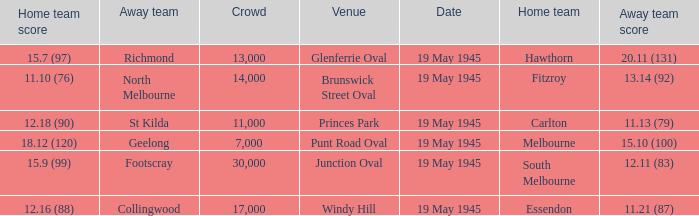Would you mind parsing the complete table? {'header': ['Home team score', 'Away team', 'Crowd', 'Venue', 'Date', 'Home team', 'Away team score'], 'rows': [['15.7 (97)', 'Richmond', '13,000', 'Glenferrie Oval', '19 May 1945', 'Hawthorn', '20.11 (131)'], ['11.10 (76)', 'North Melbourne', '14,000', 'Brunswick Street Oval', '19 May 1945', 'Fitzroy', '13.14 (92)'], ['12.18 (90)', 'St Kilda', '11,000', 'Princes Park', '19 May 1945', 'Carlton', '11.13 (79)'], ['18.12 (120)', 'Geelong', '7,000', 'Punt Road Oval', '19 May 1945', 'Melbourne', '15.10 (100)'], ['15.9 (99)', 'Footscray', '30,000', 'Junction Oval', '19 May 1945', 'South Melbourne', '12.11 (83)'], ['12.16 (88)', 'Collingwood', '17,000', 'Windy Hill', '19 May 1945', 'Essendon', '11.21 (87)']]} On which date was a game played at Junction Oval? 19 May 1945. 